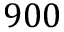<formula> <loc_0><loc_0><loc_500><loc_500>9 0 0</formula> 